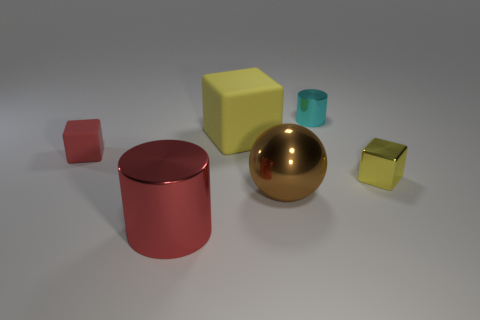Is the yellow shiny thing the same size as the red rubber cube?
Ensure brevity in your answer.  Yes. What is the ball made of?
Ensure brevity in your answer.  Metal. There is a cube that is the same material as the small cylinder; what color is it?
Offer a terse response. Yellow. Is the material of the tiny yellow object the same as the tiny object that is behind the large block?
Offer a very short reply. Yes. How many things have the same material as the big red cylinder?
Keep it short and to the point. 3. There is a tiny metallic object behind the yellow matte object; what shape is it?
Offer a very short reply. Cylinder. Does the tiny thing to the right of the tiny cyan metallic cylinder have the same material as the yellow object that is on the left side of the brown shiny sphere?
Keep it short and to the point. No. Are there any other tiny matte things that have the same shape as the tiny red object?
Your answer should be compact. No. What number of things are small things behind the small rubber block or small cyan objects?
Keep it short and to the point. 1. Is the number of yellow metallic objects that are in front of the large brown sphere greater than the number of shiny cylinders on the right side of the small cyan shiny cylinder?
Offer a very short reply. No. 